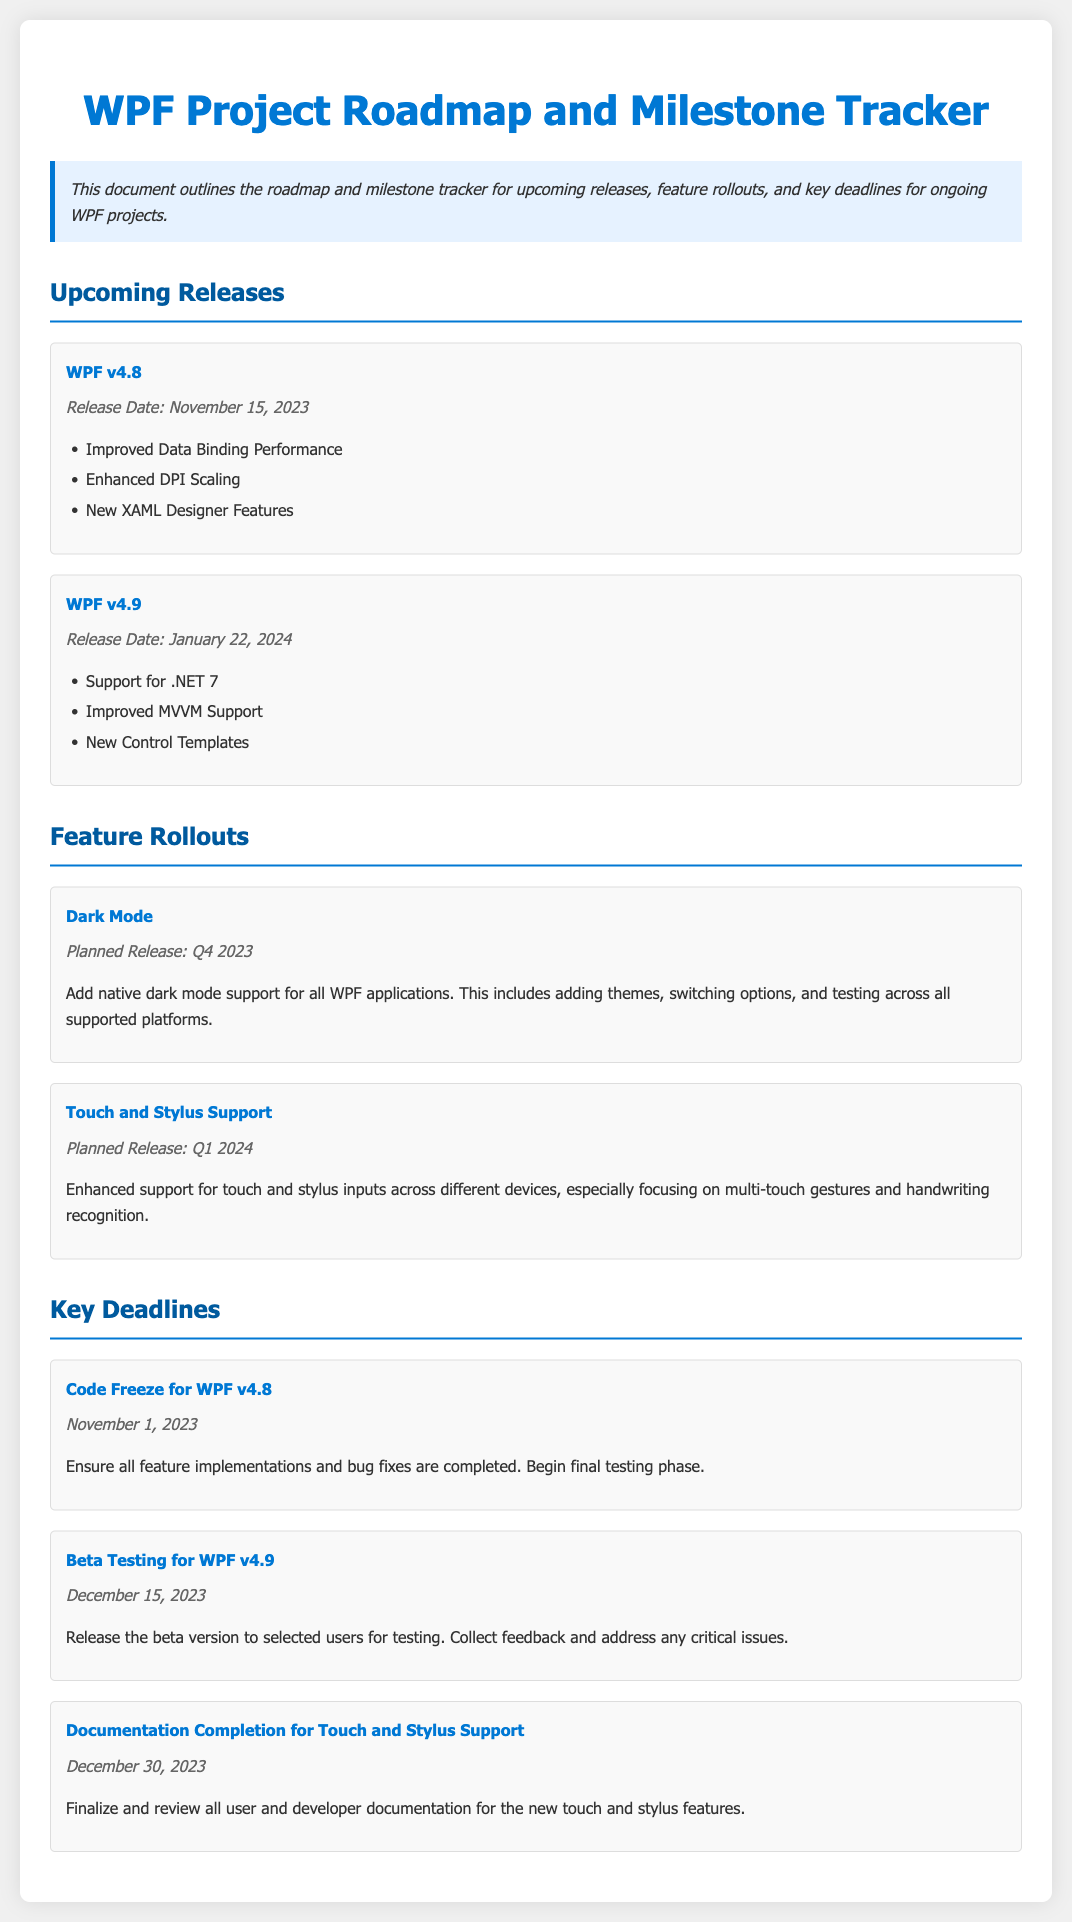What is the release date for WPF v4.8? The release date for WPF v4.8 is listed under the upcoming releases section.
Answer: November 15, 2023 What feature is planned for Q4 2023? The feature planned for Q4 2023 is found in the feature rollouts section.
Answer: Dark Mode When is the code freeze for WPF v4.8 scheduled? The code freeze date is mentioned under key deadlines.
Answer: November 1, 2023 What is a new feature added in WPF v4.9? The new features for WPF v4.9 are indicated in the upcoming releases section.
Answer: New Control Templates What is the planned release date for enhanced touch and stylus support? The planned release date is found in the feature rollouts section.
Answer: Q1 2024 What is the main focus of the touch and stylus support feature? This focus is detailed in the feature rollouts section concerning touch and stylus.
Answer: Multi-touch gestures What is the date for beta testing of WPF v4.9? The beta testing date is specified in the key deadlines section of the document.
Answer: December 15, 2023 What deadline is set for documentation completion for touch and stylus support? The deadline is identified in the key deadlines section.
Answer: December 30, 2023 